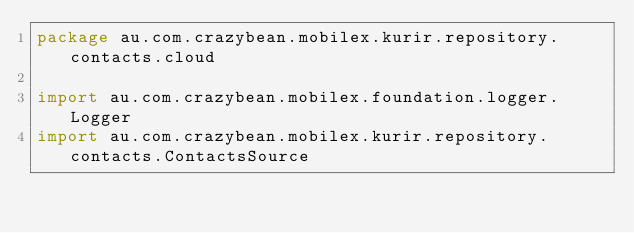Convert code to text. <code><loc_0><loc_0><loc_500><loc_500><_Kotlin_>package au.com.crazybean.mobilex.kurir.repository.contacts.cloud

import au.com.crazybean.mobilex.foundation.logger.Logger
import au.com.crazybean.mobilex.kurir.repository.contacts.ContactsSource</code> 